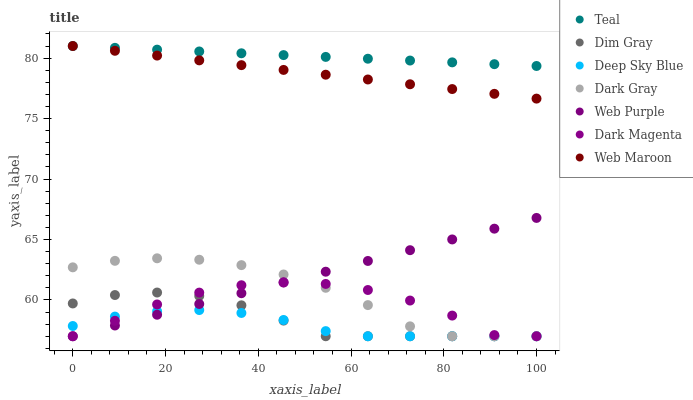Does Deep Sky Blue have the minimum area under the curve?
Answer yes or no. Yes. Does Teal have the maximum area under the curve?
Answer yes or no. Yes. Does Web Maroon have the minimum area under the curve?
Answer yes or no. No. Does Web Maroon have the maximum area under the curve?
Answer yes or no. No. Is Web Purple the smoothest?
Answer yes or no. Yes. Is Dark Magenta the roughest?
Answer yes or no. Yes. Is Teal the smoothest?
Answer yes or no. No. Is Teal the roughest?
Answer yes or no. No. Does Dim Gray have the lowest value?
Answer yes or no. Yes. Does Web Maroon have the lowest value?
Answer yes or no. No. Does Web Maroon have the highest value?
Answer yes or no. Yes. Does Dark Gray have the highest value?
Answer yes or no. No. Is Dark Magenta less than Teal?
Answer yes or no. Yes. Is Teal greater than Web Purple?
Answer yes or no. Yes. Does Dark Gray intersect Deep Sky Blue?
Answer yes or no. Yes. Is Dark Gray less than Deep Sky Blue?
Answer yes or no. No. Is Dark Gray greater than Deep Sky Blue?
Answer yes or no. No. Does Dark Magenta intersect Teal?
Answer yes or no. No. 